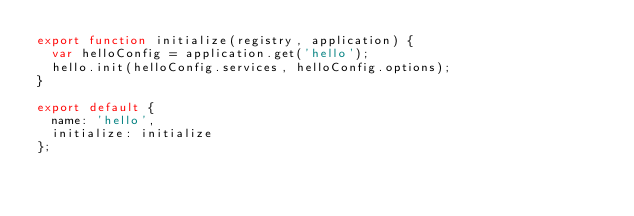Convert code to text. <code><loc_0><loc_0><loc_500><loc_500><_JavaScript_>export function initialize(registry, application) {
  var helloConfig = application.get('hello');
  hello.init(helloConfig.services, helloConfig.options);
}

export default {
  name: 'hello',
  initialize: initialize
};
</code> 